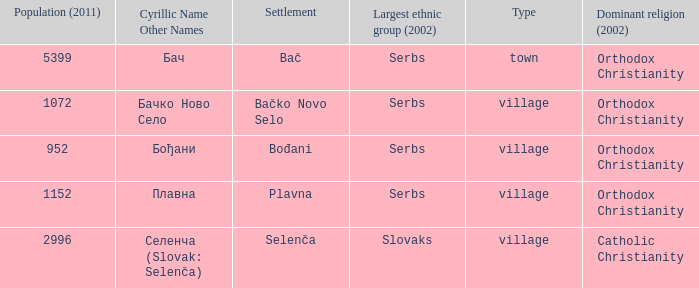Which population number is the smallest on the list? 952.0. 